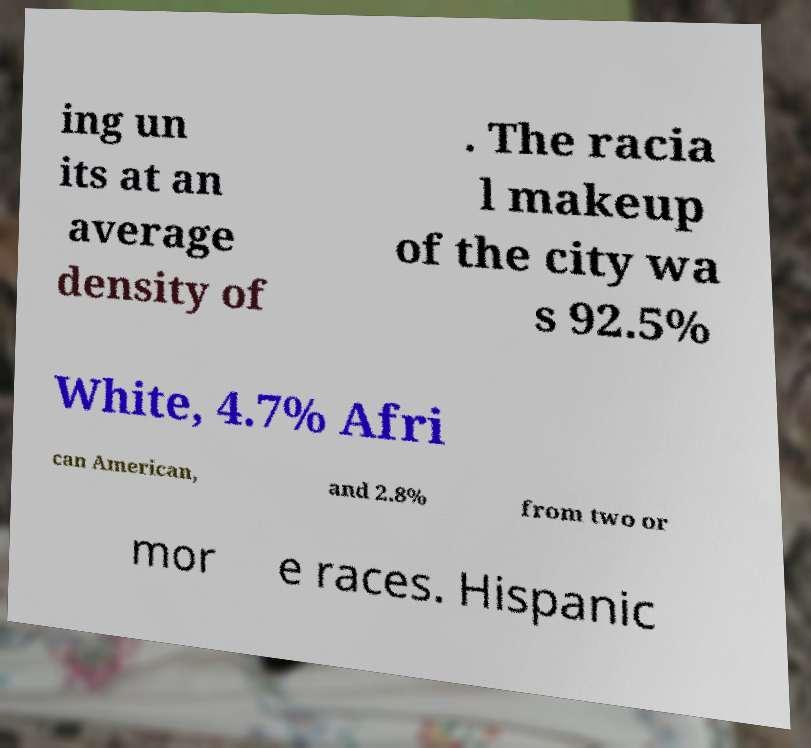There's text embedded in this image that I need extracted. Can you transcribe it verbatim? ing un its at an average density of . The racia l makeup of the city wa s 92.5% White, 4.7% Afri can American, and 2.8% from two or mor e races. Hispanic 